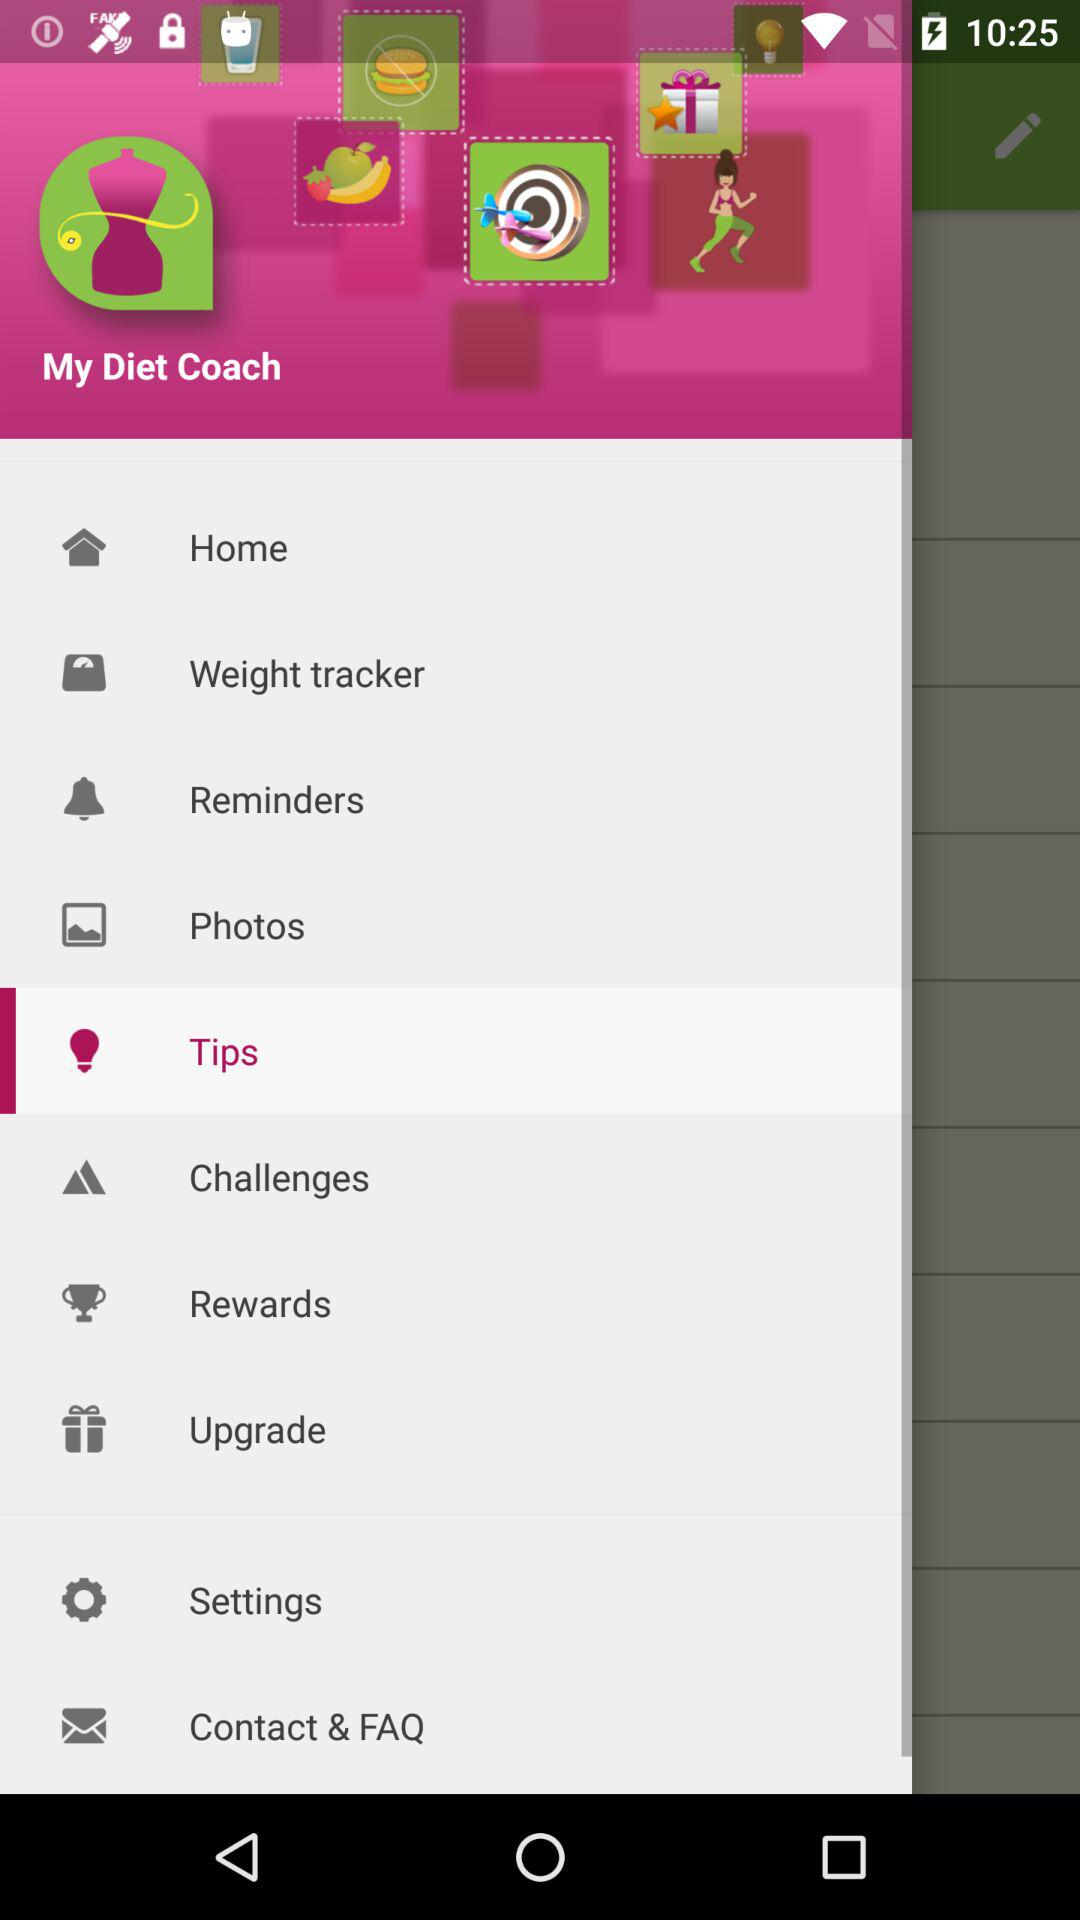What is the application name? The application's name is "My Diet Coach". 